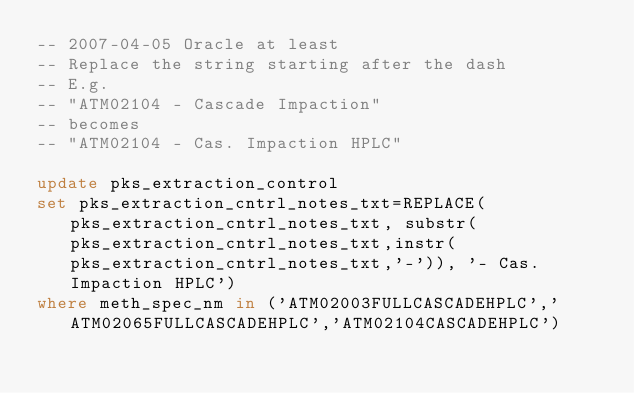<code> <loc_0><loc_0><loc_500><loc_500><_SQL_>-- 2007-04-05 Oracle at least
-- Replace the string starting after the dash
-- E.g.
-- "ATM02104 - Cascade Impaction" 
-- becomes
-- "ATM02104 - Cas. Impaction HPLC"

update pks_extraction_control
set pks_extraction_cntrl_notes_txt=REPLACE(pks_extraction_cntrl_notes_txt, substr(pks_extraction_cntrl_notes_txt,instr(pks_extraction_cntrl_notes_txt,'-')), '- Cas. Impaction HPLC')
where meth_spec_nm in ('ATM02003FULLCASCADEHPLC','ATM02065FULLCASCADEHPLC','ATM02104CASCADEHPLC')
</code> 